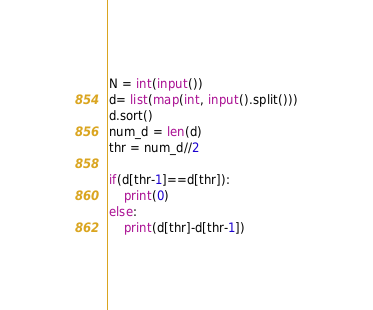<code> <loc_0><loc_0><loc_500><loc_500><_Python_>N = int(input())
d= list(map(int, input().split()))
d.sort()
num_d = len(d)
thr = num_d//2

if(d[thr-1]==d[thr]):
    print(0)
else:
    print(d[thr]-d[thr-1])
</code> 